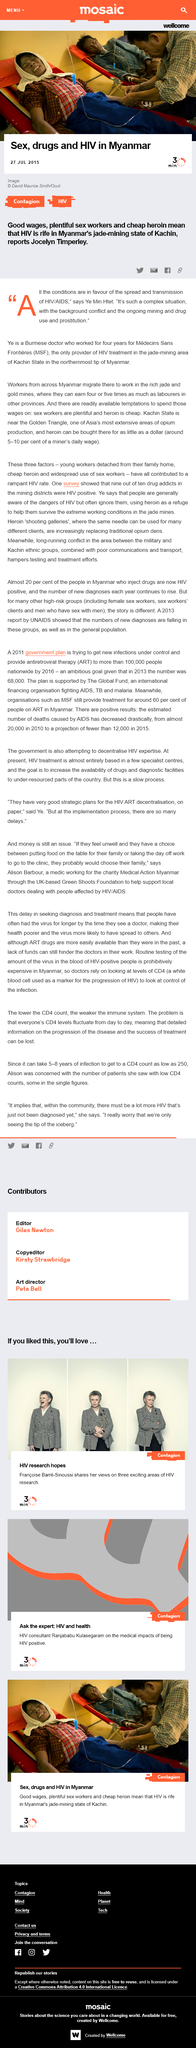Highlight a few significant elements in this photo. Medecins Sans Frontieres is the only provider of HIV treatment in the jade mining area of Kachin state, making it the sole source of medical care for individuals affected by the disease in that region. In the Kachin State, heroin can be purchased for as little as a dollar, which is a relatively low cost compared to other regions. Ye Min Htet is a Burmese doctor, who is known for his contributions to the medical field. 